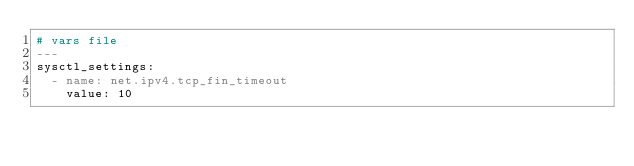<code> <loc_0><loc_0><loc_500><loc_500><_YAML_># vars file
---
sysctl_settings:
  - name: net.ipv4.tcp_fin_timeout
    value: 10
</code> 